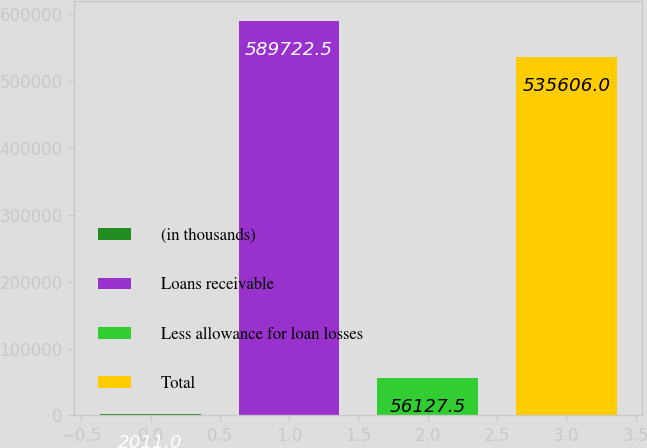Convert chart to OTSL. <chart><loc_0><loc_0><loc_500><loc_500><bar_chart><fcel>(in thousands)<fcel>Loans receivable<fcel>Less allowance for loan losses<fcel>Total<nl><fcel>2011<fcel>589722<fcel>56127.5<fcel>535606<nl></chart> 